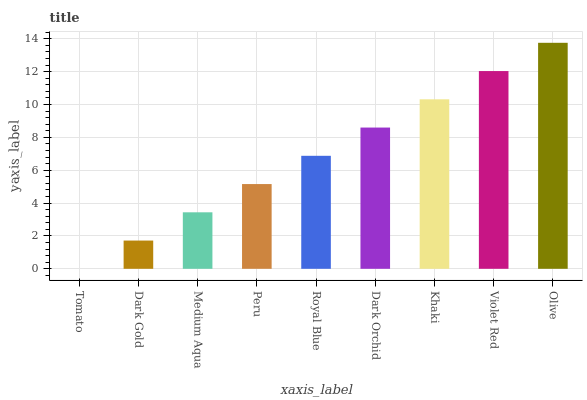Is Tomato the minimum?
Answer yes or no. Yes. Is Olive the maximum?
Answer yes or no. Yes. Is Dark Gold the minimum?
Answer yes or no. No. Is Dark Gold the maximum?
Answer yes or no. No. Is Dark Gold greater than Tomato?
Answer yes or no. Yes. Is Tomato less than Dark Gold?
Answer yes or no. Yes. Is Tomato greater than Dark Gold?
Answer yes or no. No. Is Dark Gold less than Tomato?
Answer yes or no. No. Is Royal Blue the high median?
Answer yes or no. Yes. Is Royal Blue the low median?
Answer yes or no. Yes. Is Medium Aqua the high median?
Answer yes or no. No. Is Peru the low median?
Answer yes or no. No. 